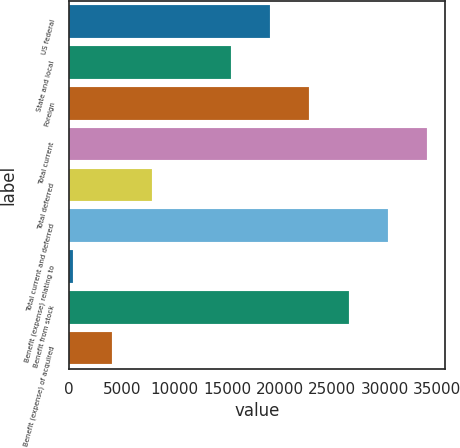Convert chart to OTSL. <chart><loc_0><loc_0><loc_500><loc_500><bar_chart><fcel>US federal<fcel>State and local<fcel>Foreign<fcel>Total current<fcel>Total deferred<fcel>Total current and deferred<fcel>Benefit (expense) relating to<fcel>Benefit from stock<fcel>Benefit (expense) of acquired<nl><fcel>19087.5<fcel>15345<fcel>22830<fcel>34057.5<fcel>7860<fcel>30315<fcel>375<fcel>26572.5<fcel>4117.5<nl></chart> 